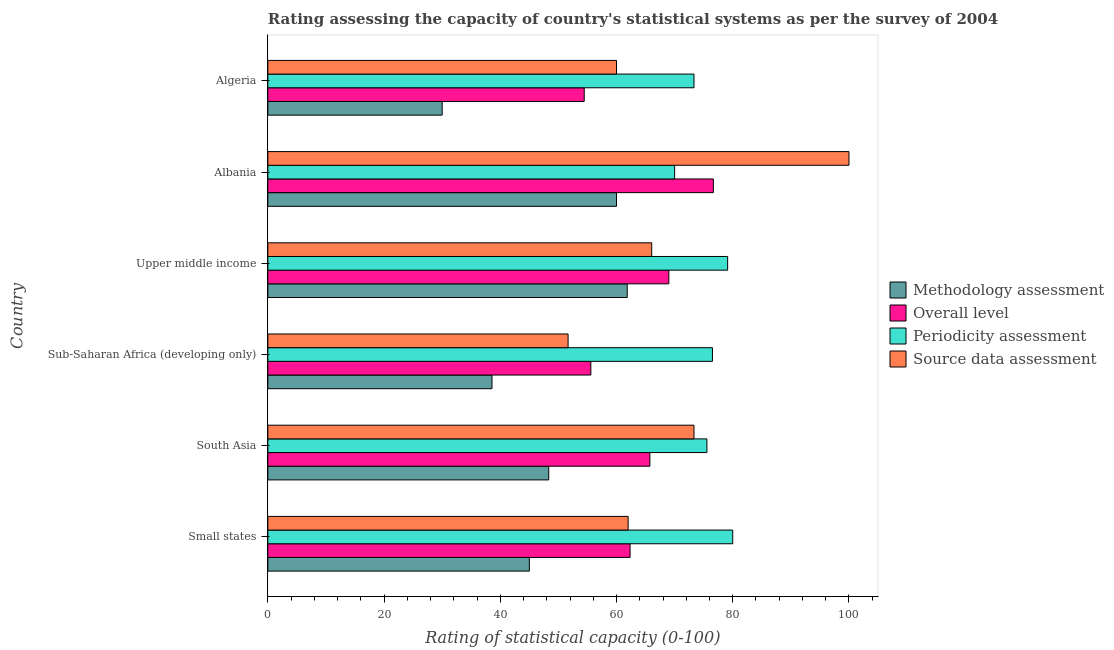How many different coloured bars are there?
Make the answer very short. 4. Are the number of bars on each tick of the Y-axis equal?
Your answer should be very brief. Yes. How many bars are there on the 3rd tick from the top?
Give a very brief answer. 4. How many bars are there on the 5th tick from the bottom?
Your answer should be very brief. 4. What is the label of the 3rd group of bars from the top?
Your answer should be very brief. Upper middle income. What is the source data assessment rating in Algeria?
Keep it short and to the point. 60. Across all countries, what is the maximum periodicity assessment rating?
Your answer should be very brief. 80. Across all countries, what is the minimum overall level rating?
Your response must be concise. 54.44. In which country was the methodology assessment rating maximum?
Offer a terse response. Upper middle income. In which country was the methodology assessment rating minimum?
Give a very brief answer. Algeria. What is the total overall level rating in the graph?
Your answer should be very brief. 383.77. What is the difference between the source data assessment rating in Albania and that in Algeria?
Your response must be concise. 40. What is the difference between the source data assessment rating in Albania and the overall level rating in Algeria?
Offer a terse response. 45.56. What is the average overall level rating per country?
Keep it short and to the point. 63.96. What is the difference between the methodology assessment rating and source data assessment rating in Sub-Saharan Africa (developing only)?
Your answer should be very brief. -13.1. In how many countries, is the methodology assessment rating greater than 56 ?
Keep it short and to the point. 2. What is the ratio of the overall level rating in Sub-Saharan Africa (developing only) to that in Upper middle income?
Provide a succinct answer. 0.81. Is the overall level rating in South Asia less than that in Upper middle income?
Provide a succinct answer. Yes. What is the difference between the highest and the second highest periodicity assessment rating?
Your response must be concise. 0.88. What is the difference between the highest and the lowest source data assessment rating?
Ensure brevity in your answer.  48.33. In how many countries, is the methodology assessment rating greater than the average methodology assessment rating taken over all countries?
Your answer should be compact. 3. Is it the case that in every country, the sum of the methodology assessment rating and source data assessment rating is greater than the sum of periodicity assessment rating and overall level rating?
Your answer should be very brief. No. What does the 4th bar from the top in Albania represents?
Give a very brief answer. Methodology assessment. What does the 4th bar from the bottom in Small states represents?
Your answer should be compact. Source data assessment. Is it the case that in every country, the sum of the methodology assessment rating and overall level rating is greater than the periodicity assessment rating?
Provide a short and direct response. Yes. How many countries are there in the graph?
Your answer should be compact. 6. What is the difference between two consecutive major ticks on the X-axis?
Offer a terse response. 20. Are the values on the major ticks of X-axis written in scientific E-notation?
Your answer should be very brief. No. Does the graph contain grids?
Provide a short and direct response. No. Where does the legend appear in the graph?
Ensure brevity in your answer.  Center right. How are the legend labels stacked?
Offer a very short reply. Vertical. What is the title of the graph?
Make the answer very short. Rating assessing the capacity of country's statistical systems as per the survey of 2004 . What is the label or title of the X-axis?
Offer a terse response. Rating of statistical capacity (0-100). What is the Rating of statistical capacity (0-100) in Overall level in Small states?
Offer a terse response. 62.33. What is the Rating of statistical capacity (0-100) in Periodicity assessment in Small states?
Keep it short and to the point. 80. What is the Rating of statistical capacity (0-100) of Source data assessment in Small states?
Offer a terse response. 62. What is the Rating of statistical capacity (0-100) of Methodology assessment in South Asia?
Your answer should be very brief. 48.33. What is the Rating of statistical capacity (0-100) in Overall level in South Asia?
Your answer should be compact. 65.74. What is the Rating of statistical capacity (0-100) in Periodicity assessment in South Asia?
Your answer should be very brief. 75.56. What is the Rating of statistical capacity (0-100) of Source data assessment in South Asia?
Keep it short and to the point. 73.33. What is the Rating of statistical capacity (0-100) of Methodology assessment in Sub-Saharan Africa (developing only)?
Provide a short and direct response. 38.57. What is the Rating of statistical capacity (0-100) in Overall level in Sub-Saharan Africa (developing only)?
Give a very brief answer. 55.58. What is the Rating of statistical capacity (0-100) in Periodicity assessment in Sub-Saharan Africa (developing only)?
Give a very brief answer. 76.51. What is the Rating of statistical capacity (0-100) of Source data assessment in Sub-Saharan Africa (developing only)?
Offer a terse response. 51.67. What is the Rating of statistical capacity (0-100) in Methodology assessment in Upper middle income?
Provide a succinct answer. 61.84. What is the Rating of statistical capacity (0-100) of Overall level in Upper middle income?
Your response must be concise. 69.01. What is the Rating of statistical capacity (0-100) of Periodicity assessment in Upper middle income?
Provide a short and direct response. 79.12. What is the Rating of statistical capacity (0-100) of Source data assessment in Upper middle income?
Offer a terse response. 66.05. What is the Rating of statistical capacity (0-100) of Methodology assessment in Albania?
Provide a short and direct response. 60. What is the Rating of statistical capacity (0-100) of Overall level in Albania?
Provide a succinct answer. 76.67. What is the Rating of statistical capacity (0-100) in Periodicity assessment in Albania?
Give a very brief answer. 70. What is the Rating of statistical capacity (0-100) of Source data assessment in Albania?
Ensure brevity in your answer.  100. What is the Rating of statistical capacity (0-100) of Overall level in Algeria?
Your answer should be compact. 54.44. What is the Rating of statistical capacity (0-100) of Periodicity assessment in Algeria?
Keep it short and to the point. 73.33. Across all countries, what is the maximum Rating of statistical capacity (0-100) in Methodology assessment?
Offer a terse response. 61.84. Across all countries, what is the maximum Rating of statistical capacity (0-100) of Overall level?
Provide a succinct answer. 76.67. Across all countries, what is the minimum Rating of statistical capacity (0-100) of Overall level?
Make the answer very short. 54.44. Across all countries, what is the minimum Rating of statistical capacity (0-100) of Periodicity assessment?
Ensure brevity in your answer.  70. Across all countries, what is the minimum Rating of statistical capacity (0-100) in Source data assessment?
Ensure brevity in your answer.  51.67. What is the total Rating of statistical capacity (0-100) in Methodology assessment in the graph?
Make the answer very short. 283.75. What is the total Rating of statistical capacity (0-100) of Overall level in the graph?
Keep it short and to the point. 383.77. What is the total Rating of statistical capacity (0-100) in Periodicity assessment in the graph?
Your response must be concise. 454.52. What is the total Rating of statistical capacity (0-100) in Source data assessment in the graph?
Keep it short and to the point. 413.05. What is the difference between the Rating of statistical capacity (0-100) in Overall level in Small states and that in South Asia?
Provide a succinct answer. -3.41. What is the difference between the Rating of statistical capacity (0-100) of Periodicity assessment in Small states and that in South Asia?
Your response must be concise. 4.44. What is the difference between the Rating of statistical capacity (0-100) of Source data assessment in Small states and that in South Asia?
Offer a very short reply. -11.33. What is the difference between the Rating of statistical capacity (0-100) of Methodology assessment in Small states and that in Sub-Saharan Africa (developing only)?
Your answer should be very brief. 6.43. What is the difference between the Rating of statistical capacity (0-100) of Overall level in Small states and that in Sub-Saharan Africa (developing only)?
Offer a very short reply. 6.75. What is the difference between the Rating of statistical capacity (0-100) in Periodicity assessment in Small states and that in Sub-Saharan Africa (developing only)?
Provide a short and direct response. 3.49. What is the difference between the Rating of statistical capacity (0-100) in Source data assessment in Small states and that in Sub-Saharan Africa (developing only)?
Give a very brief answer. 10.33. What is the difference between the Rating of statistical capacity (0-100) of Methodology assessment in Small states and that in Upper middle income?
Your answer should be very brief. -16.84. What is the difference between the Rating of statistical capacity (0-100) of Overall level in Small states and that in Upper middle income?
Offer a very short reply. -6.67. What is the difference between the Rating of statistical capacity (0-100) of Periodicity assessment in Small states and that in Upper middle income?
Provide a succinct answer. 0.88. What is the difference between the Rating of statistical capacity (0-100) in Source data assessment in Small states and that in Upper middle income?
Provide a succinct answer. -4.05. What is the difference between the Rating of statistical capacity (0-100) in Methodology assessment in Small states and that in Albania?
Offer a terse response. -15. What is the difference between the Rating of statistical capacity (0-100) in Overall level in Small states and that in Albania?
Make the answer very short. -14.33. What is the difference between the Rating of statistical capacity (0-100) of Source data assessment in Small states and that in Albania?
Ensure brevity in your answer.  -38. What is the difference between the Rating of statistical capacity (0-100) of Overall level in Small states and that in Algeria?
Offer a terse response. 7.89. What is the difference between the Rating of statistical capacity (0-100) in Periodicity assessment in Small states and that in Algeria?
Your answer should be very brief. 6.67. What is the difference between the Rating of statistical capacity (0-100) of Methodology assessment in South Asia and that in Sub-Saharan Africa (developing only)?
Make the answer very short. 9.76. What is the difference between the Rating of statistical capacity (0-100) in Overall level in South Asia and that in Sub-Saharan Africa (developing only)?
Provide a succinct answer. 10.16. What is the difference between the Rating of statistical capacity (0-100) in Periodicity assessment in South Asia and that in Sub-Saharan Africa (developing only)?
Offer a terse response. -0.95. What is the difference between the Rating of statistical capacity (0-100) in Source data assessment in South Asia and that in Sub-Saharan Africa (developing only)?
Offer a very short reply. 21.67. What is the difference between the Rating of statistical capacity (0-100) of Methodology assessment in South Asia and that in Upper middle income?
Ensure brevity in your answer.  -13.51. What is the difference between the Rating of statistical capacity (0-100) of Overall level in South Asia and that in Upper middle income?
Provide a short and direct response. -3.27. What is the difference between the Rating of statistical capacity (0-100) of Periodicity assessment in South Asia and that in Upper middle income?
Provide a succinct answer. -3.57. What is the difference between the Rating of statistical capacity (0-100) in Source data assessment in South Asia and that in Upper middle income?
Your response must be concise. 7.28. What is the difference between the Rating of statistical capacity (0-100) of Methodology assessment in South Asia and that in Albania?
Offer a terse response. -11.67. What is the difference between the Rating of statistical capacity (0-100) of Overall level in South Asia and that in Albania?
Your answer should be compact. -10.93. What is the difference between the Rating of statistical capacity (0-100) in Periodicity assessment in South Asia and that in Albania?
Make the answer very short. 5.56. What is the difference between the Rating of statistical capacity (0-100) in Source data assessment in South Asia and that in Albania?
Your response must be concise. -26.67. What is the difference between the Rating of statistical capacity (0-100) in Methodology assessment in South Asia and that in Algeria?
Offer a terse response. 18.33. What is the difference between the Rating of statistical capacity (0-100) of Overall level in South Asia and that in Algeria?
Provide a short and direct response. 11.3. What is the difference between the Rating of statistical capacity (0-100) in Periodicity assessment in South Asia and that in Algeria?
Make the answer very short. 2.22. What is the difference between the Rating of statistical capacity (0-100) of Source data assessment in South Asia and that in Algeria?
Ensure brevity in your answer.  13.33. What is the difference between the Rating of statistical capacity (0-100) of Methodology assessment in Sub-Saharan Africa (developing only) and that in Upper middle income?
Offer a terse response. -23.27. What is the difference between the Rating of statistical capacity (0-100) of Overall level in Sub-Saharan Africa (developing only) and that in Upper middle income?
Offer a terse response. -13.42. What is the difference between the Rating of statistical capacity (0-100) of Periodicity assessment in Sub-Saharan Africa (developing only) and that in Upper middle income?
Provide a short and direct response. -2.61. What is the difference between the Rating of statistical capacity (0-100) of Source data assessment in Sub-Saharan Africa (developing only) and that in Upper middle income?
Your answer should be very brief. -14.39. What is the difference between the Rating of statistical capacity (0-100) in Methodology assessment in Sub-Saharan Africa (developing only) and that in Albania?
Provide a succinct answer. -21.43. What is the difference between the Rating of statistical capacity (0-100) in Overall level in Sub-Saharan Africa (developing only) and that in Albania?
Keep it short and to the point. -21.08. What is the difference between the Rating of statistical capacity (0-100) in Periodicity assessment in Sub-Saharan Africa (developing only) and that in Albania?
Offer a terse response. 6.51. What is the difference between the Rating of statistical capacity (0-100) in Source data assessment in Sub-Saharan Africa (developing only) and that in Albania?
Offer a terse response. -48.33. What is the difference between the Rating of statistical capacity (0-100) in Methodology assessment in Sub-Saharan Africa (developing only) and that in Algeria?
Ensure brevity in your answer.  8.57. What is the difference between the Rating of statistical capacity (0-100) of Overall level in Sub-Saharan Africa (developing only) and that in Algeria?
Offer a terse response. 1.14. What is the difference between the Rating of statistical capacity (0-100) of Periodicity assessment in Sub-Saharan Africa (developing only) and that in Algeria?
Offer a terse response. 3.17. What is the difference between the Rating of statistical capacity (0-100) of Source data assessment in Sub-Saharan Africa (developing only) and that in Algeria?
Provide a succinct answer. -8.33. What is the difference between the Rating of statistical capacity (0-100) in Methodology assessment in Upper middle income and that in Albania?
Keep it short and to the point. 1.84. What is the difference between the Rating of statistical capacity (0-100) of Overall level in Upper middle income and that in Albania?
Ensure brevity in your answer.  -7.66. What is the difference between the Rating of statistical capacity (0-100) of Periodicity assessment in Upper middle income and that in Albania?
Make the answer very short. 9.12. What is the difference between the Rating of statistical capacity (0-100) in Source data assessment in Upper middle income and that in Albania?
Make the answer very short. -33.95. What is the difference between the Rating of statistical capacity (0-100) in Methodology assessment in Upper middle income and that in Algeria?
Your answer should be very brief. 31.84. What is the difference between the Rating of statistical capacity (0-100) in Overall level in Upper middle income and that in Algeria?
Your answer should be compact. 14.56. What is the difference between the Rating of statistical capacity (0-100) in Periodicity assessment in Upper middle income and that in Algeria?
Provide a short and direct response. 5.79. What is the difference between the Rating of statistical capacity (0-100) in Source data assessment in Upper middle income and that in Algeria?
Provide a succinct answer. 6.05. What is the difference between the Rating of statistical capacity (0-100) in Overall level in Albania and that in Algeria?
Make the answer very short. 22.22. What is the difference between the Rating of statistical capacity (0-100) of Source data assessment in Albania and that in Algeria?
Ensure brevity in your answer.  40. What is the difference between the Rating of statistical capacity (0-100) of Methodology assessment in Small states and the Rating of statistical capacity (0-100) of Overall level in South Asia?
Ensure brevity in your answer.  -20.74. What is the difference between the Rating of statistical capacity (0-100) of Methodology assessment in Small states and the Rating of statistical capacity (0-100) of Periodicity assessment in South Asia?
Your answer should be very brief. -30.56. What is the difference between the Rating of statistical capacity (0-100) in Methodology assessment in Small states and the Rating of statistical capacity (0-100) in Source data assessment in South Asia?
Your answer should be compact. -28.33. What is the difference between the Rating of statistical capacity (0-100) in Overall level in Small states and the Rating of statistical capacity (0-100) in Periodicity assessment in South Asia?
Give a very brief answer. -13.22. What is the difference between the Rating of statistical capacity (0-100) in Periodicity assessment in Small states and the Rating of statistical capacity (0-100) in Source data assessment in South Asia?
Ensure brevity in your answer.  6.67. What is the difference between the Rating of statistical capacity (0-100) in Methodology assessment in Small states and the Rating of statistical capacity (0-100) in Overall level in Sub-Saharan Africa (developing only)?
Provide a succinct answer. -10.58. What is the difference between the Rating of statistical capacity (0-100) in Methodology assessment in Small states and the Rating of statistical capacity (0-100) in Periodicity assessment in Sub-Saharan Africa (developing only)?
Make the answer very short. -31.51. What is the difference between the Rating of statistical capacity (0-100) in Methodology assessment in Small states and the Rating of statistical capacity (0-100) in Source data assessment in Sub-Saharan Africa (developing only)?
Keep it short and to the point. -6.67. What is the difference between the Rating of statistical capacity (0-100) in Overall level in Small states and the Rating of statistical capacity (0-100) in Periodicity assessment in Sub-Saharan Africa (developing only)?
Make the answer very short. -14.17. What is the difference between the Rating of statistical capacity (0-100) in Overall level in Small states and the Rating of statistical capacity (0-100) in Source data assessment in Sub-Saharan Africa (developing only)?
Ensure brevity in your answer.  10.67. What is the difference between the Rating of statistical capacity (0-100) of Periodicity assessment in Small states and the Rating of statistical capacity (0-100) of Source data assessment in Sub-Saharan Africa (developing only)?
Provide a succinct answer. 28.33. What is the difference between the Rating of statistical capacity (0-100) in Methodology assessment in Small states and the Rating of statistical capacity (0-100) in Overall level in Upper middle income?
Make the answer very short. -24.01. What is the difference between the Rating of statistical capacity (0-100) of Methodology assessment in Small states and the Rating of statistical capacity (0-100) of Periodicity assessment in Upper middle income?
Provide a short and direct response. -34.12. What is the difference between the Rating of statistical capacity (0-100) in Methodology assessment in Small states and the Rating of statistical capacity (0-100) in Source data assessment in Upper middle income?
Keep it short and to the point. -21.05. What is the difference between the Rating of statistical capacity (0-100) in Overall level in Small states and the Rating of statistical capacity (0-100) in Periodicity assessment in Upper middle income?
Offer a very short reply. -16.79. What is the difference between the Rating of statistical capacity (0-100) of Overall level in Small states and the Rating of statistical capacity (0-100) of Source data assessment in Upper middle income?
Provide a succinct answer. -3.72. What is the difference between the Rating of statistical capacity (0-100) of Periodicity assessment in Small states and the Rating of statistical capacity (0-100) of Source data assessment in Upper middle income?
Your answer should be compact. 13.95. What is the difference between the Rating of statistical capacity (0-100) of Methodology assessment in Small states and the Rating of statistical capacity (0-100) of Overall level in Albania?
Make the answer very short. -31.67. What is the difference between the Rating of statistical capacity (0-100) of Methodology assessment in Small states and the Rating of statistical capacity (0-100) of Source data assessment in Albania?
Offer a terse response. -55. What is the difference between the Rating of statistical capacity (0-100) of Overall level in Small states and the Rating of statistical capacity (0-100) of Periodicity assessment in Albania?
Offer a very short reply. -7.67. What is the difference between the Rating of statistical capacity (0-100) of Overall level in Small states and the Rating of statistical capacity (0-100) of Source data assessment in Albania?
Your answer should be very brief. -37.67. What is the difference between the Rating of statistical capacity (0-100) in Periodicity assessment in Small states and the Rating of statistical capacity (0-100) in Source data assessment in Albania?
Your answer should be compact. -20. What is the difference between the Rating of statistical capacity (0-100) in Methodology assessment in Small states and the Rating of statistical capacity (0-100) in Overall level in Algeria?
Your answer should be compact. -9.44. What is the difference between the Rating of statistical capacity (0-100) in Methodology assessment in Small states and the Rating of statistical capacity (0-100) in Periodicity assessment in Algeria?
Provide a succinct answer. -28.33. What is the difference between the Rating of statistical capacity (0-100) in Methodology assessment in Small states and the Rating of statistical capacity (0-100) in Source data assessment in Algeria?
Give a very brief answer. -15. What is the difference between the Rating of statistical capacity (0-100) of Overall level in Small states and the Rating of statistical capacity (0-100) of Periodicity assessment in Algeria?
Offer a terse response. -11. What is the difference between the Rating of statistical capacity (0-100) in Overall level in Small states and the Rating of statistical capacity (0-100) in Source data assessment in Algeria?
Provide a succinct answer. 2.33. What is the difference between the Rating of statistical capacity (0-100) in Methodology assessment in South Asia and the Rating of statistical capacity (0-100) in Overall level in Sub-Saharan Africa (developing only)?
Offer a terse response. -7.25. What is the difference between the Rating of statistical capacity (0-100) in Methodology assessment in South Asia and the Rating of statistical capacity (0-100) in Periodicity assessment in Sub-Saharan Africa (developing only)?
Offer a very short reply. -28.17. What is the difference between the Rating of statistical capacity (0-100) of Methodology assessment in South Asia and the Rating of statistical capacity (0-100) of Source data assessment in Sub-Saharan Africa (developing only)?
Give a very brief answer. -3.33. What is the difference between the Rating of statistical capacity (0-100) in Overall level in South Asia and the Rating of statistical capacity (0-100) in Periodicity assessment in Sub-Saharan Africa (developing only)?
Your answer should be compact. -10.77. What is the difference between the Rating of statistical capacity (0-100) in Overall level in South Asia and the Rating of statistical capacity (0-100) in Source data assessment in Sub-Saharan Africa (developing only)?
Offer a very short reply. 14.07. What is the difference between the Rating of statistical capacity (0-100) of Periodicity assessment in South Asia and the Rating of statistical capacity (0-100) of Source data assessment in Sub-Saharan Africa (developing only)?
Offer a very short reply. 23.89. What is the difference between the Rating of statistical capacity (0-100) of Methodology assessment in South Asia and the Rating of statistical capacity (0-100) of Overall level in Upper middle income?
Provide a succinct answer. -20.67. What is the difference between the Rating of statistical capacity (0-100) in Methodology assessment in South Asia and the Rating of statistical capacity (0-100) in Periodicity assessment in Upper middle income?
Keep it short and to the point. -30.79. What is the difference between the Rating of statistical capacity (0-100) in Methodology assessment in South Asia and the Rating of statistical capacity (0-100) in Source data assessment in Upper middle income?
Offer a terse response. -17.72. What is the difference between the Rating of statistical capacity (0-100) in Overall level in South Asia and the Rating of statistical capacity (0-100) in Periodicity assessment in Upper middle income?
Give a very brief answer. -13.38. What is the difference between the Rating of statistical capacity (0-100) in Overall level in South Asia and the Rating of statistical capacity (0-100) in Source data assessment in Upper middle income?
Your answer should be very brief. -0.31. What is the difference between the Rating of statistical capacity (0-100) in Periodicity assessment in South Asia and the Rating of statistical capacity (0-100) in Source data assessment in Upper middle income?
Your answer should be very brief. 9.5. What is the difference between the Rating of statistical capacity (0-100) in Methodology assessment in South Asia and the Rating of statistical capacity (0-100) in Overall level in Albania?
Your response must be concise. -28.33. What is the difference between the Rating of statistical capacity (0-100) in Methodology assessment in South Asia and the Rating of statistical capacity (0-100) in Periodicity assessment in Albania?
Offer a terse response. -21.67. What is the difference between the Rating of statistical capacity (0-100) in Methodology assessment in South Asia and the Rating of statistical capacity (0-100) in Source data assessment in Albania?
Keep it short and to the point. -51.67. What is the difference between the Rating of statistical capacity (0-100) in Overall level in South Asia and the Rating of statistical capacity (0-100) in Periodicity assessment in Albania?
Give a very brief answer. -4.26. What is the difference between the Rating of statistical capacity (0-100) in Overall level in South Asia and the Rating of statistical capacity (0-100) in Source data assessment in Albania?
Keep it short and to the point. -34.26. What is the difference between the Rating of statistical capacity (0-100) in Periodicity assessment in South Asia and the Rating of statistical capacity (0-100) in Source data assessment in Albania?
Offer a very short reply. -24.44. What is the difference between the Rating of statistical capacity (0-100) of Methodology assessment in South Asia and the Rating of statistical capacity (0-100) of Overall level in Algeria?
Give a very brief answer. -6.11. What is the difference between the Rating of statistical capacity (0-100) of Methodology assessment in South Asia and the Rating of statistical capacity (0-100) of Source data assessment in Algeria?
Provide a succinct answer. -11.67. What is the difference between the Rating of statistical capacity (0-100) of Overall level in South Asia and the Rating of statistical capacity (0-100) of Periodicity assessment in Algeria?
Offer a very short reply. -7.59. What is the difference between the Rating of statistical capacity (0-100) in Overall level in South Asia and the Rating of statistical capacity (0-100) in Source data assessment in Algeria?
Keep it short and to the point. 5.74. What is the difference between the Rating of statistical capacity (0-100) in Periodicity assessment in South Asia and the Rating of statistical capacity (0-100) in Source data assessment in Algeria?
Your answer should be very brief. 15.56. What is the difference between the Rating of statistical capacity (0-100) in Methodology assessment in Sub-Saharan Africa (developing only) and the Rating of statistical capacity (0-100) in Overall level in Upper middle income?
Provide a short and direct response. -30.43. What is the difference between the Rating of statistical capacity (0-100) in Methodology assessment in Sub-Saharan Africa (developing only) and the Rating of statistical capacity (0-100) in Periodicity assessment in Upper middle income?
Offer a terse response. -40.55. What is the difference between the Rating of statistical capacity (0-100) in Methodology assessment in Sub-Saharan Africa (developing only) and the Rating of statistical capacity (0-100) in Source data assessment in Upper middle income?
Ensure brevity in your answer.  -27.48. What is the difference between the Rating of statistical capacity (0-100) in Overall level in Sub-Saharan Africa (developing only) and the Rating of statistical capacity (0-100) in Periodicity assessment in Upper middle income?
Your answer should be compact. -23.54. What is the difference between the Rating of statistical capacity (0-100) in Overall level in Sub-Saharan Africa (developing only) and the Rating of statistical capacity (0-100) in Source data assessment in Upper middle income?
Provide a short and direct response. -10.47. What is the difference between the Rating of statistical capacity (0-100) of Periodicity assessment in Sub-Saharan Africa (developing only) and the Rating of statistical capacity (0-100) of Source data assessment in Upper middle income?
Ensure brevity in your answer.  10.46. What is the difference between the Rating of statistical capacity (0-100) of Methodology assessment in Sub-Saharan Africa (developing only) and the Rating of statistical capacity (0-100) of Overall level in Albania?
Your answer should be compact. -38.1. What is the difference between the Rating of statistical capacity (0-100) of Methodology assessment in Sub-Saharan Africa (developing only) and the Rating of statistical capacity (0-100) of Periodicity assessment in Albania?
Ensure brevity in your answer.  -31.43. What is the difference between the Rating of statistical capacity (0-100) in Methodology assessment in Sub-Saharan Africa (developing only) and the Rating of statistical capacity (0-100) in Source data assessment in Albania?
Your response must be concise. -61.43. What is the difference between the Rating of statistical capacity (0-100) in Overall level in Sub-Saharan Africa (developing only) and the Rating of statistical capacity (0-100) in Periodicity assessment in Albania?
Make the answer very short. -14.42. What is the difference between the Rating of statistical capacity (0-100) of Overall level in Sub-Saharan Africa (developing only) and the Rating of statistical capacity (0-100) of Source data assessment in Albania?
Keep it short and to the point. -44.42. What is the difference between the Rating of statistical capacity (0-100) of Periodicity assessment in Sub-Saharan Africa (developing only) and the Rating of statistical capacity (0-100) of Source data assessment in Albania?
Give a very brief answer. -23.49. What is the difference between the Rating of statistical capacity (0-100) in Methodology assessment in Sub-Saharan Africa (developing only) and the Rating of statistical capacity (0-100) in Overall level in Algeria?
Offer a terse response. -15.87. What is the difference between the Rating of statistical capacity (0-100) of Methodology assessment in Sub-Saharan Africa (developing only) and the Rating of statistical capacity (0-100) of Periodicity assessment in Algeria?
Provide a short and direct response. -34.76. What is the difference between the Rating of statistical capacity (0-100) of Methodology assessment in Sub-Saharan Africa (developing only) and the Rating of statistical capacity (0-100) of Source data assessment in Algeria?
Keep it short and to the point. -21.43. What is the difference between the Rating of statistical capacity (0-100) in Overall level in Sub-Saharan Africa (developing only) and the Rating of statistical capacity (0-100) in Periodicity assessment in Algeria?
Make the answer very short. -17.75. What is the difference between the Rating of statistical capacity (0-100) in Overall level in Sub-Saharan Africa (developing only) and the Rating of statistical capacity (0-100) in Source data assessment in Algeria?
Ensure brevity in your answer.  -4.42. What is the difference between the Rating of statistical capacity (0-100) of Periodicity assessment in Sub-Saharan Africa (developing only) and the Rating of statistical capacity (0-100) of Source data assessment in Algeria?
Ensure brevity in your answer.  16.51. What is the difference between the Rating of statistical capacity (0-100) in Methodology assessment in Upper middle income and the Rating of statistical capacity (0-100) in Overall level in Albania?
Give a very brief answer. -14.82. What is the difference between the Rating of statistical capacity (0-100) in Methodology assessment in Upper middle income and the Rating of statistical capacity (0-100) in Periodicity assessment in Albania?
Make the answer very short. -8.16. What is the difference between the Rating of statistical capacity (0-100) in Methodology assessment in Upper middle income and the Rating of statistical capacity (0-100) in Source data assessment in Albania?
Offer a very short reply. -38.16. What is the difference between the Rating of statistical capacity (0-100) in Overall level in Upper middle income and the Rating of statistical capacity (0-100) in Periodicity assessment in Albania?
Offer a very short reply. -0.99. What is the difference between the Rating of statistical capacity (0-100) in Overall level in Upper middle income and the Rating of statistical capacity (0-100) in Source data assessment in Albania?
Your answer should be compact. -30.99. What is the difference between the Rating of statistical capacity (0-100) of Periodicity assessment in Upper middle income and the Rating of statistical capacity (0-100) of Source data assessment in Albania?
Ensure brevity in your answer.  -20.88. What is the difference between the Rating of statistical capacity (0-100) in Methodology assessment in Upper middle income and the Rating of statistical capacity (0-100) in Overall level in Algeria?
Your answer should be compact. 7.4. What is the difference between the Rating of statistical capacity (0-100) in Methodology assessment in Upper middle income and the Rating of statistical capacity (0-100) in Periodicity assessment in Algeria?
Your answer should be compact. -11.49. What is the difference between the Rating of statistical capacity (0-100) of Methodology assessment in Upper middle income and the Rating of statistical capacity (0-100) of Source data assessment in Algeria?
Offer a very short reply. 1.84. What is the difference between the Rating of statistical capacity (0-100) in Overall level in Upper middle income and the Rating of statistical capacity (0-100) in Periodicity assessment in Algeria?
Offer a very short reply. -4.33. What is the difference between the Rating of statistical capacity (0-100) of Overall level in Upper middle income and the Rating of statistical capacity (0-100) of Source data assessment in Algeria?
Offer a very short reply. 9.01. What is the difference between the Rating of statistical capacity (0-100) in Periodicity assessment in Upper middle income and the Rating of statistical capacity (0-100) in Source data assessment in Algeria?
Your answer should be compact. 19.12. What is the difference between the Rating of statistical capacity (0-100) in Methodology assessment in Albania and the Rating of statistical capacity (0-100) in Overall level in Algeria?
Provide a short and direct response. 5.56. What is the difference between the Rating of statistical capacity (0-100) in Methodology assessment in Albania and the Rating of statistical capacity (0-100) in Periodicity assessment in Algeria?
Ensure brevity in your answer.  -13.33. What is the difference between the Rating of statistical capacity (0-100) of Methodology assessment in Albania and the Rating of statistical capacity (0-100) of Source data assessment in Algeria?
Offer a very short reply. 0. What is the difference between the Rating of statistical capacity (0-100) in Overall level in Albania and the Rating of statistical capacity (0-100) in Periodicity assessment in Algeria?
Ensure brevity in your answer.  3.33. What is the difference between the Rating of statistical capacity (0-100) in Overall level in Albania and the Rating of statistical capacity (0-100) in Source data assessment in Algeria?
Provide a succinct answer. 16.67. What is the average Rating of statistical capacity (0-100) of Methodology assessment per country?
Ensure brevity in your answer.  47.29. What is the average Rating of statistical capacity (0-100) of Overall level per country?
Ensure brevity in your answer.  63.96. What is the average Rating of statistical capacity (0-100) in Periodicity assessment per country?
Your response must be concise. 75.75. What is the average Rating of statistical capacity (0-100) of Source data assessment per country?
Offer a terse response. 68.84. What is the difference between the Rating of statistical capacity (0-100) in Methodology assessment and Rating of statistical capacity (0-100) in Overall level in Small states?
Your answer should be compact. -17.33. What is the difference between the Rating of statistical capacity (0-100) of Methodology assessment and Rating of statistical capacity (0-100) of Periodicity assessment in Small states?
Ensure brevity in your answer.  -35. What is the difference between the Rating of statistical capacity (0-100) in Methodology assessment and Rating of statistical capacity (0-100) in Source data assessment in Small states?
Offer a very short reply. -17. What is the difference between the Rating of statistical capacity (0-100) in Overall level and Rating of statistical capacity (0-100) in Periodicity assessment in Small states?
Keep it short and to the point. -17.67. What is the difference between the Rating of statistical capacity (0-100) in Methodology assessment and Rating of statistical capacity (0-100) in Overall level in South Asia?
Make the answer very short. -17.41. What is the difference between the Rating of statistical capacity (0-100) in Methodology assessment and Rating of statistical capacity (0-100) in Periodicity assessment in South Asia?
Give a very brief answer. -27.22. What is the difference between the Rating of statistical capacity (0-100) in Overall level and Rating of statistical capacity (0-100) in Periodicity assessment in South Asia?
Provide a short and direct response. -9.81. What is the difference between the Rating of statistical capacity (0-100) of Overall level and Rating of statistical capacity (0-100) of Source data assessment in South Asia?
Provide a short and direct response. -7.59. What is the difference between the Rating of statistical capacity (0-100) of Periodicity assessment and Rating of statistical capacity (0-100) of Source data assessment in South Asia?
Your response must be concise. 2.22. What is the difference between the Rating of statistical capacity (0-100) of Methodology assessment and Rating of statistical capacity (0-100) of Overall level in Sub-Saharan Africa (developing only)?
Keep it short and to the point. -17.01. What is the difference between the Rating of statistical capacity (0-100) in Methodology assessment and Rating of statistical capacity (0-100) in Periodicity assessment in Sub-Saharan Africa (developing only)?
Offer a very short reply. -37.94. What is the difference between the Rating of statistical capacity (0-100) in Methodology assessment and Rating of statistical capacity (0-100) in Source data assessment in Sub-Saharan Africa (developing only)?
Provide a succinct answer. -13.1. What is the difference between the Rating of statistical capacity (0-100) in Overall level and Rating of statistical capacity (0-100) in Periodicity assessment in Sub-Saharan Africa (developing only)?
Ensure brevity in your answer.  -20.93. What is the difference between the Rating of statistical capacity (0-100) of Overall level and Rating of statistical capacity (0-100) of Source data assessment in Sub-Saharan Africa (developing only)?
Ensure brevity in your answer.  3.92. What is the difference between the Rating of statistical capacity (0-100) in Periodicity assessment and Rating of statistical capacity (0-100) in Source data assessment in Sub-Saharan Africa (developing only)?
Your response must be concise. 24.84. What is the difference between the Rating of statistical capacity (0-100) of Methodology assessment and Rating of statistical capacity (0-100) of Overall level in Upper middle income?
Your response must be concise. -7.16. What is the difference between the Rating of statistical capacity (0-100) of Methodology assessment and Rating of statistical capacity (0-100) of Periodicity assessment in Upper middle income?
Ensure brevity in your answer.  -17.28. What is the difference between the Rating of statistical capacity (0-100) of Methodology assessment and Rating of statistical capacity (0-100) of Source data assessment in Upper middle income?
Keep it short and to the point. -4.21. What is the difference between the Rating of statistical capacity (0-100) in Overall level and Rating of statistical capacity (0-100) in Periodicity assessment in Upper middle income?
Provide a succinct answer. -10.12. What is the difference between the Rating of statistical capacity (0-100) of Overall level and Rating of statistical capacity (0-100) of Source data assessment in Upper middle income?
Make the answer very short. 2.95. What is the difference between the Rating of statistical capacity (0-100) in Periodicity assessment and Rating of statistical capacity (0-100) in Source data assessment in Upper middle income?
Your answer should be compact. 13.07. What is the difference between the Rating of statistical capacity (0-100) of Methodology assessment and Rating of statistical capacity (0-100) of Overall level in Albania?
Provide a short and direct response. -16.67. What is the difference between the Rating of statistical capacity (0-100) in Methodology assessment and Rating of statistical capacity (0-100) in Periodicity assessment in Albania?
Ensure brevity in your answer.  -10. What is the difference between the Rating of statistical capacity (0-100) in Methodology assessment and Rating of statistical capacity (0-100) in Source data assessment in Albania?
Make the answer very short. -40. What is the difference between the Rating of statistical capacity (0-100) of Overall level and Rating of statistical capacity (0-100) of Source data assessment in Albania?
Provide a short and direct response. -23.33. What is the difference between the Rating of statistical capacity (0-100) in Periodicity assessment and Rating of statistical capacity (0-100) in Source data assessment in Albania?
Offer a very short reply. -30. What is the difference between the Rating of statistical capacity (0-100) in Methodology assessment and Rating of statistical capacity (0-100) in Overall level in Algeria?
Your answer should be very brief. -24.44. What is the difference between the Rating of statistical capacity (0-100) of Methodology assessment and Rating of statistical capacity (0-100) of Periodicity assessment in Algeria?
Keep it short and to the point. -43.33. What is the difference between the Rating of statistical capacity (0-100) of Methodology assessment and Rating of statistical capacity (0-100) of Source data assessment in Algeria?
Offer a very short reply. -30. What is the difference between the Rating of statistical capacity (0-100) in Overall level and Rating of statistical capacity (0-100) in Periodicity assessment in Algeria?
Your answer should be very brief. -18.89. What is the difference between the Rating of statistical capacity (0-100) in Overall level and Rating of statistical capacity (0-100) in Source data assessment in Algeria?
Offer a terse response. -5.56. What is the difference between the Rating of statistical capacity (0-100) in Periodicity assessment and Rating of statistical capacity (0-100) in Source data assessment in Algeria?
Make the answer very short. 13.33. What is the ratio of the Rating of statistical capacity (0-100) of Overall level in Small states to that in South Asia?
Ensure brevity in your answer.  0.95. What is the ratio of the Rating of statistical capacity (0-100) in Periodicity assessment in Small states to that in South Asia?
Ensure brevity in your answer.  1.06. What is the ratio of the Rating of statistical capacity (0-100) in Source data assessment in Small states to that in South Asia?
Provide a short and direct response. 0.85. What is the ratio of the Rating of statistical capacity (0-100) of Methodology assessment in Small states to that in Sub-Saharan Africa (developing only)?
Offer a terse response. 1.17. What is the ratio of the Rating of statistical capacity (0-100) in Overall level in Small states to that in Sub-Saharan Africa (developing only)?
Offer a terse response. 1.12. What is the ratio of the Rating of statistical capacity (0-100) in Periodicity assessment in Small states to that in Sub-Saharan Africa (developing only)?
Offer a very short reply. 1.05. What is the ratio of the Rating of statistical capacity (0-100) of Methodology assessment in Small states to that in Upper middle income?
Provide a succinct answer. 0.73. What is the ratio of the Rating of statistical capacity (0-100) in Overall level in Small states to that in Upper middle income?
Provide a succinct answer. 0.9. What is the ratio of the Rating of statistical capacity (0-100) in Periodicity assessment in Small states to that in Upper middle income?
Offer a terse response. 1.01. What is the ratio of the Rating of statistical capacity (0-100) of Source data assessment in Small states to that in Upper middle income?
Make the answer very short. 0.94. What is the ratio of the Rating of statistical capacity (0-100) in Methodology assessment in Small states to that in Albania?
Make the answer very short. 0.75. What is the ratio of the Rating of statistical capacity (0-100) in Overall level in Small states to that in Albania?
Your answer should be compact. 0.81. What is the ratio of the Rating of statistical capacity (0-100) in Source data assessment in Small states to that in Albania?
Give a very brief answer. 0.62. What is the ratio of the Rating of statistical capacity (0-100) of Methodology assessment in Small states to that in Algeria?
Offer a terse response. 1.5. What is the ratio of the Rating of statistical capacity (0-100) of Overall level in Small states to that in Algeria?
Give a very brief answer. 1.14. What is the ratio of the Rating of statistical capacity (0-100) in Source data assessment in Small states to that in Algeria?
Give a very brief answer. 1.03. What is the ratio of the Rating of statistical capacity (0-100) of Methodology assessment in South Asia to that in Sub-Saharan Africa (developing only)?
Ensure brevity in your answer.  1.25. What is the ratio of the Rating of statistical capacity (0-100) of Overall level in South Asia to that in Sub-Saharan Africa (developing only)?
Provide a succinct answer. 1.18. What is the ratio of the Rating of statistical capacity (0-100) of Periodicity assessment in South Asia to that in Sub-Saharan Africa (developing only)?
Your answer should be very brief. 0.99. What is the ratio of the Rating of statistical capacity (0-100) of Source data assessment in South Asia to that in Sub-Saharan Africa (developing only)?
Ensure brevity in your answer.  1.42. What is the ratio of the Rating of statistical capacity (0-100) of Methodology assessment in South Asia to that in Upper middle income?
Keep it short and to the point. 0.78. What is the ratio of the Rating of statistical capacity (0-100) of Overall level in South Asia to that in Upper middle income?
Give a very brief answer. 0.95. What is the ratio of the Rating of statistical capacity (0-100) in Periodicity assessment in South Asia to that in Upper middle income?
Your answer should be very brief. 0.95. What is the ratio of the Rating of statistical capacity (0-100) in Source data assessment in South Asia to that in Upper middle income?
Provide a short and direct response. 1.11. What is the ratio of the Rating of statistical capacity (0-100) in Methodology assessment in South Asia to that in Albania?
Keep it short and to the point. 0.81. What is the ratio of the Rating of statistical capacity (0-100) in Overall level in South Asia to that in Albania?
Provide a short and direct response. 0.86. What is the ratio of the Rating of statistical capacity (0-100) in Periodicity assessment in South Asia to that in Albania?
Offer a terse response. 1.08. What is the ratio of the Rating of statistical capacity (0-100) of Source data assessment in South Asia to that in Albania?
Make the answer very short. 0.73. What is the ratio of the Rating of statistical capacity (0-100) of Methodology assessment in South Asia to that in Algeria?
Give a very brief answer. 1.61. What is the ratio of the Rating of statistical capacity (0-100) of Overall level in South Asia to that in Algeria?
Offer a terse response. 1.21. What is the ratio of the Rating of statistical capacity (0-100) in Periodicity assessment in South Asia to that in Algeria?
Ensure brevity in your answer.  1.03. What is the ratio of the Rating of statistical capacity (0-100) of Source data assessment in South Asia to that in Algeria?
Give a very brief answer. 1.22. What is the ratio of the Rating of statistical capacity (0-100) in Methodology assessment in Sub-Saharan Africa (developing only) to that in Upper middle income?
Your response must be concise. 0.62. What is the ratio of the Rating of statistical capacity (0-100) of Overall level in Sub-Saharan Africa (developing only) to that in Upper middle income?
Make the answer very short. 0.81. What is the ratio of the Rating of statistical capacity (0-100) of Source data assessment in Sub-Saharan Africa (developing only) to that in Upper middle income?
Make the answer very short. 0.78. What is the ratio of the Rating of statistical capacity (0-100) in Methodology assessment in Sub-Saharan Africa (developing only) to that in Albania?
Offer a terse response. 0.64. What is the ratio of the Rating of statistical capacity (0-100) in Overall level in Sub-Saharan Africa (developing only) to that in Albania?
Make the answer very short. 0.72. What is the ratio of the Rating of statistical capacity (0-100) of Periodicity assessment in Sub-Saharan Africa (developing only) to that in Albania?
Make the answer very short. 1.09. What is the ratio of the Rating of statistical capacity (0-100) of Source data assessment in Sub-Saharan Africa (developing only) to that in Albania?
Give a very brief answer. 0.52. What is the ratio of the Rating of statistical capacity (0-100) of Methodology assessment in Sub-Saharan Africa (developing only) to that in Algeria?
Your answer should be compact. 1.29. What is the ratio of the Rating of statistical capacity (0-100) of Overall level in Sub-Saharan Africa (developing only) to that in Algeria?
Offer a very short reply. 1.02. What is the ratio of the Rating of statistical capacity (0-100) in Periodicity assessment in Sub-Saharan Africa (developing only) to that in Algeria?
Offer a very short reply. 1.04. What is the ratio of the Rating of statistical capacity (0-100) of Source data assessment in Sub-Saharan Africa (developing only) to that in Algeria?
Your answer should be compact. 0.86. What is the ratio of the Rating of statistical capacity (0-100) in Methodology assessment in Upper middle income to that in Albania?
Your response must be concise. 1.03. What is the ratio of the Rating of statistical capacity (0-100) in Overall level in Upper middle income to that in Albania?
Make the answer very short. 0.9. What is the ratio of the Rating of statistical capacity (0-100) in Periodicity assessment in Upper middle income to that in Albania?
Make the answer very short. 1.13. What is the ratio of the Rating of statistical capacity (0-100) in Source data assessment in Upper middle income to that in Albania?
Your response must be concise. 0.66. What is the ratio of the Rating of statistical capacity (0-100) of Methodology assessment in Upper middle income to that in Algeria?
Your answer should be compact. 2.06. What is the ratio of the Rating of statistical capacity (0-100) of Overall level in Upper middle income to that in Algeria?
Your answer should be compact. 1.27. What is the ratio of the Rating of statistical capacity (0-100) in Periodicity assessment in Upper middle income to that in Algeria?
Provide a short and direct response. 1.08. What is the ratio of the Rating of statistical capacity (0-100) in Source data assessment in Upper middle income to that in Algeria?
Keep it short and to the point. 1.1. What is the ratio of the Rating of statistical capacity (0-100) of Methodology assessment in Albania to that in Algeria?
Give a very brief answer. 2. What is the ratio of the Rating of statistical capacity (0-100) in Overall level in Albania to that in Algeria?
Offer a terse response. 1.41. What is the ratio of the Rating of statistical capacity (0-100) in Periodicity assessment in Albania to that in Algeria?
Ensure brevity in your answer.  0.95. What is the difference between the highest and the second highest Rating of statistical capacity (0-100) in Methodology assessment?
Ensure brevity in your answer.  1.84. What is the difference between the highest and the second highest Rating of statistical capacity (0-100) of Overall level?
Your answer should be very brief. 7.66. What is the difference between the highest and the second highest Rating of statistical capacity (0-100) in Periodicity assessment?
Offer a very short reply. 0.88. What is the difference between the highest and the second highest Rating of statistical capacity (0-100) in Source data assessment?
Provide a short and direct response. 26.67. What is the difference between the highest and the lowest Rating of statistical capacity (0-100) in Methodology assessment?
Offer a very short reply. 31.84. What is the difference between the highest and the lowest Rating of statistical capacity (0-100) in Overall level?
Your response must be concise. 22.22. What is the difference between the highest and the lowest Rating of statistical capacity (0-100) of Periodicity assessment?
Provide a succinct answer. 10. What is the difference between the highest and the lowest Rating of statistical capacity (0-100) of Source data assessment?
Keep it short and to the point. 48.33. 